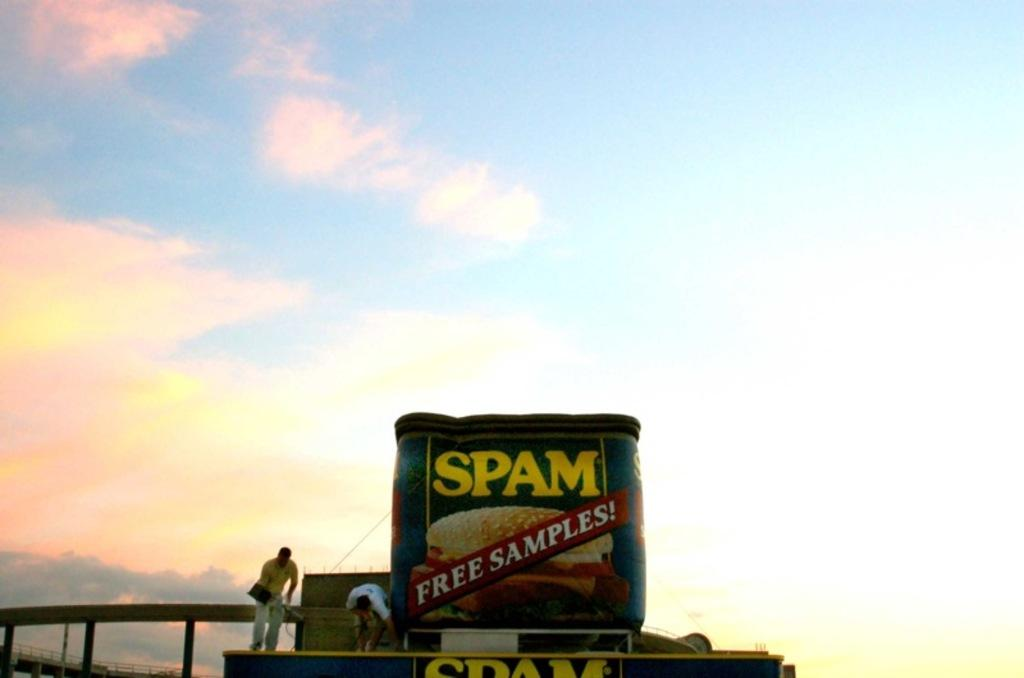<image>
Relay a brief, clear account of the picture shown. A large inflatable can of Spam advertises "Free Samples!" 